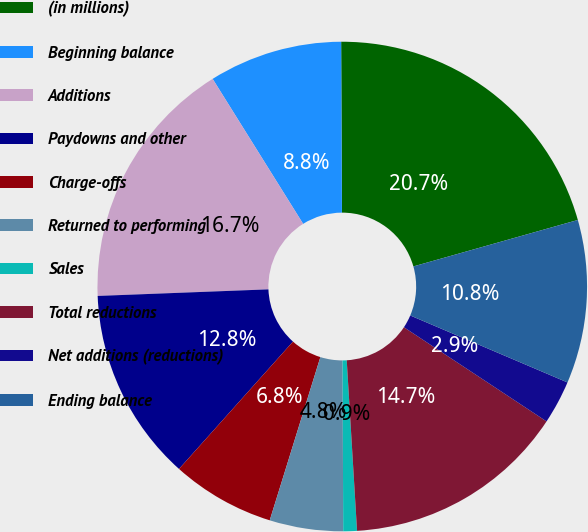Convert chart. <chart><loc_0><loc_0><loc_500><loc_500><pie_chart><fcel>(in millions)<fcel>Beginning balance<fcel>Additions<fcel>Paydowns and other<fcel>Charge-offs<fcel>Returned to performing<fcel>Sales<fcel>Total reductions<fcel>Net additions (reductions)<fcel>Ending balance<nl><fcel>20.69%<fcel>8.81%<fcel>16.73%<fcel>12.77%<fcel>6.83%<fcel>4.85%<fcel>0.9%<fcel>14.75%<fcel>2.88%<fcel>10.79%<nl></chart> 